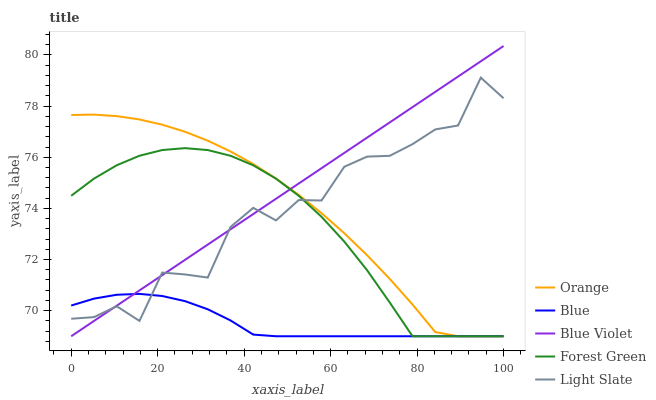Does Blue have the minimum area under the curve?
Answer yes or no. Yes. Does Blue Violet have the maximum area under the curve?
Answer yes or no. Yes. Does Forest Green have the minimum area under the curve?
Answer yes or no. No. Does Forest Green have the maximum area under the curve?
Answer yes or no. No. Is Blue Violet the smoothest?
Answer yes or no. Yes. Is Light Slate the roughest?
Answer yes or no. Yes. Is Blue the smoothest?
Answer yes or no. No. Is Blue the roughest?
Answer yes or no. No. Does Light Slate have the lowest value?
Answer yes or no. No. Does Blue Violet have the highest value?
Answer yes or no. Yes. Does Forest Green have the highest value?
Answer yes or no. No. Does Forest Green intersect Light Slate?
Answer yes or no. Yes. Is Forest Green less than Light Slate?
Answer yes or no. No. Is Forest Green greater than Light Slate?
Answer yes or no. No. 